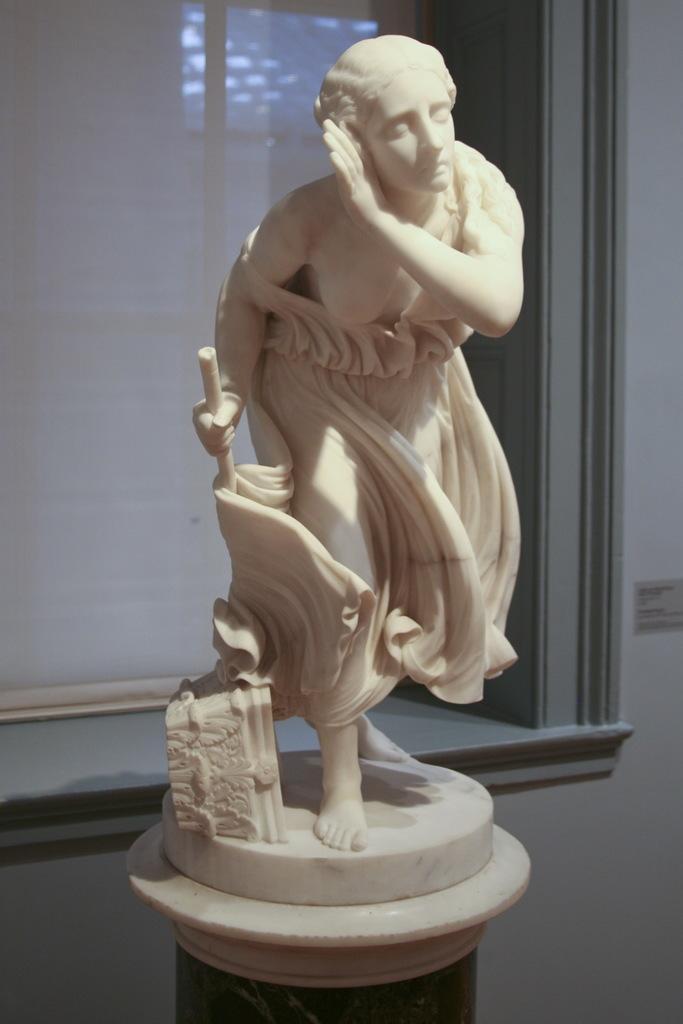Please provide a concise description of this image. In this picture we can see a statue on the platform and in the background we can see the wall, window, curtain. 